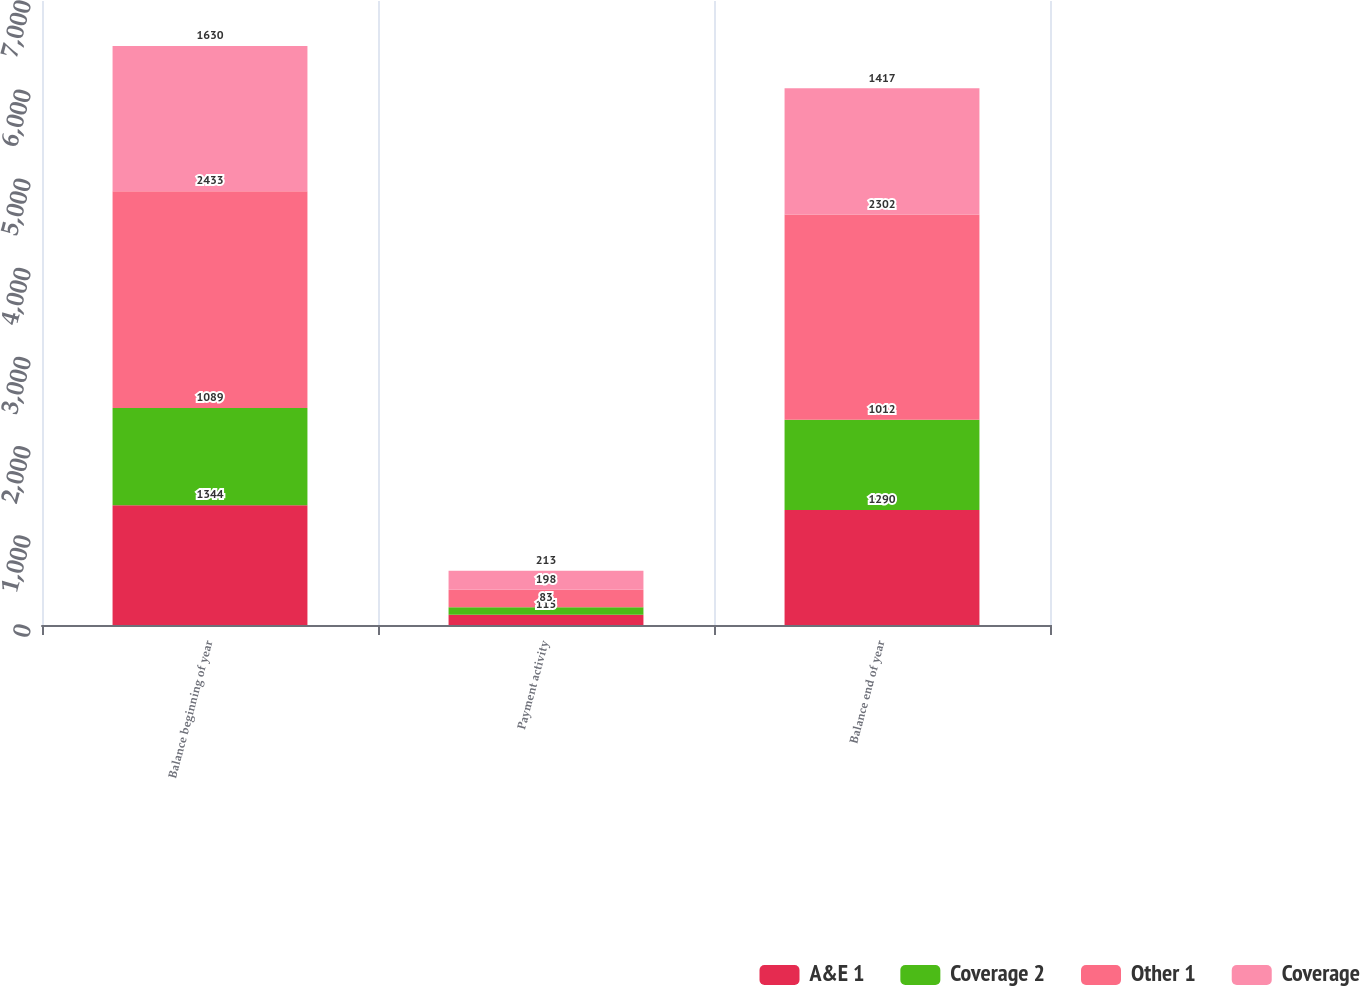Convert chart. <chart><loc_0><loc_0><loc_500><loc_500><stacked_bar_chart><ecel><fcel>Balance beginning of year<fcel>Payment activity<fcel>Balance end of year<nl><fcel>A&E 1<fcel>1344<fcel>115<fcel>1290<nl><fcel>Coverage 2<fcel>1089<fcel>83<fcel>1012<nl><fcel>Other 1<fcel>2433<fcel>198<fcel>2302<nl><fcel>Coverage<fcel>1630<fcel>213<fcel>1417<nl></chart> 